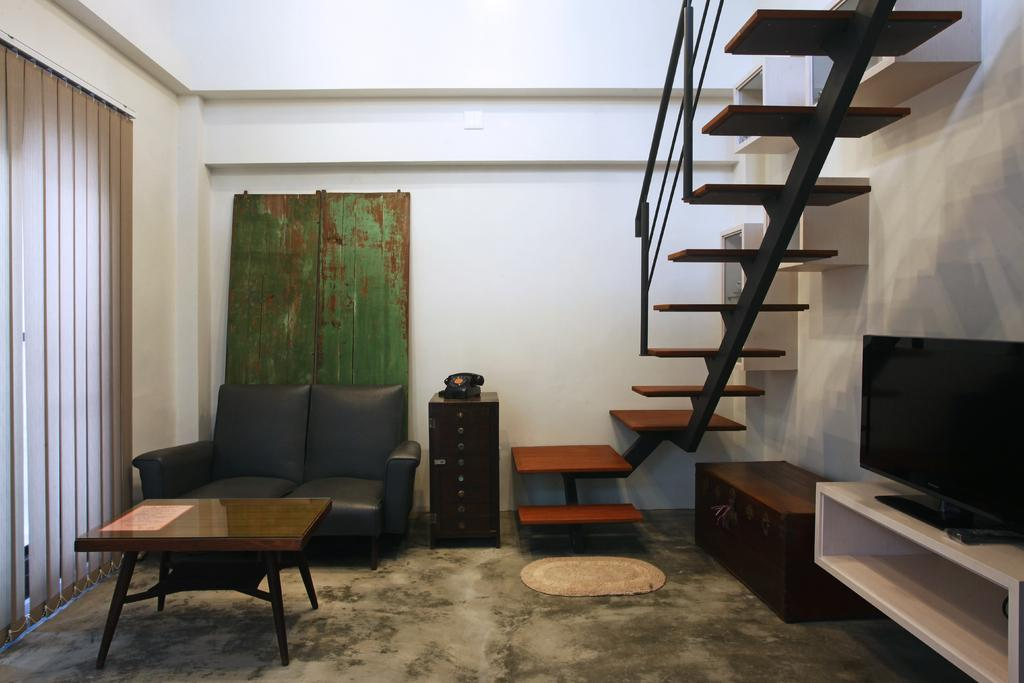What type of furniture is present in the image? There is a sofa in the image. What electronic device can be seen in the image? There is a telephone and a television in the image. Are there any architectural features visible in the image? Yes, there are stairs in the image. What other piece of furniture is present in the image? There is a table in the image. Can you see any notebooks or feathers on the table in the image? There is no mention of notebooks or feathers in the image; only a sofa, telephone, television, stairs, and table are present. What type of bushes are visible outside the window in the image? There is no window or bushes mentioned in the image; only a sofa, telephone, television, stairs, and table are present. 